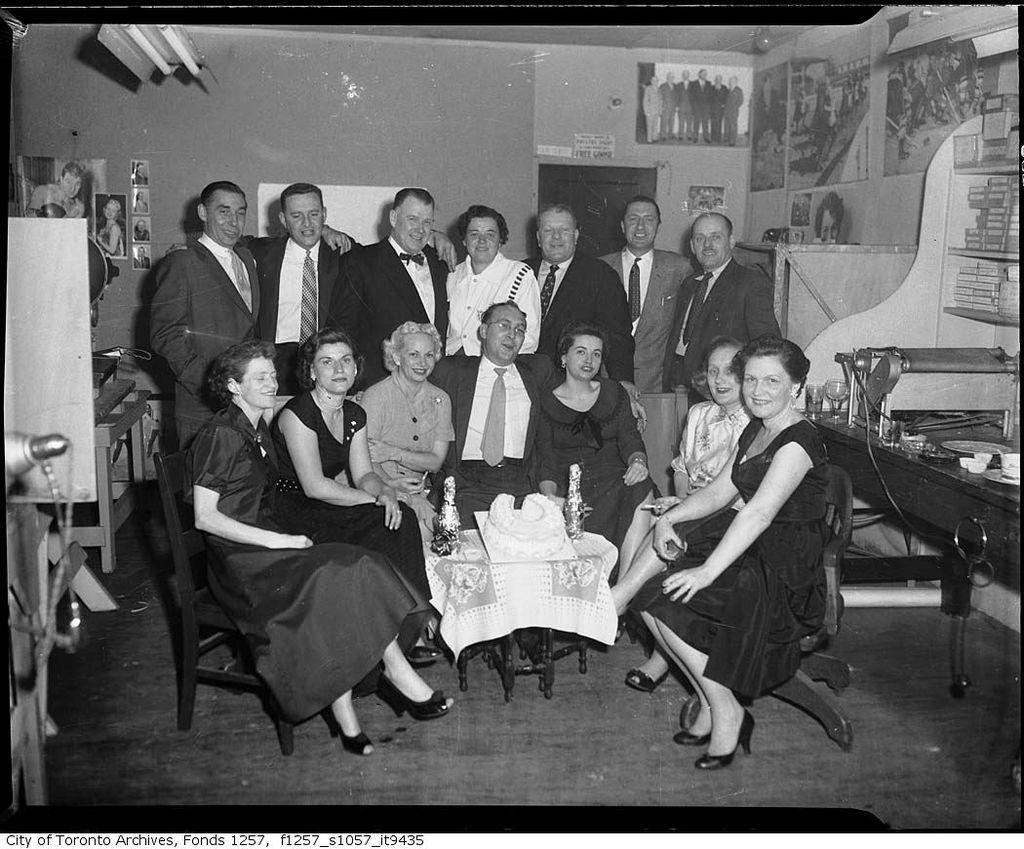What is a prominent feature in the image? There is a wall in the image. What are the people in the image doing? The people in the image are standing and sitting. What piece of furniture is present in the image? There is a table in the image. What objects can be seen on the table? There are bottles present on the table. What type of pancake is being served at the event in the image? There is no event or pancake present in the image. How does the wall pull the people closer together in the image? The wall does not pull the people closer together in the image; it is a stationary feature. 